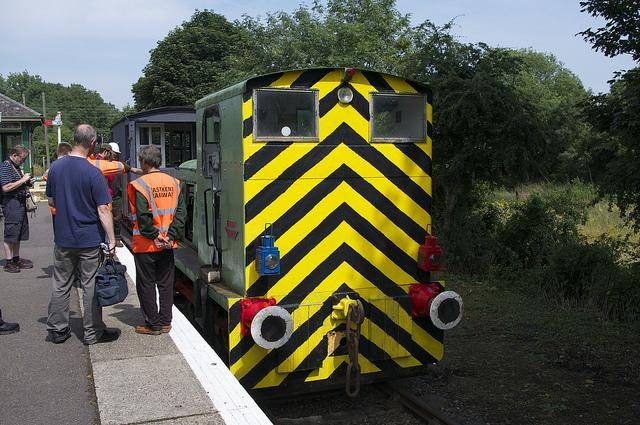Why are the men wearing orange vests?

Choices:
A) camouflage
B) fashion
C) dress code
D) visibility visibility 